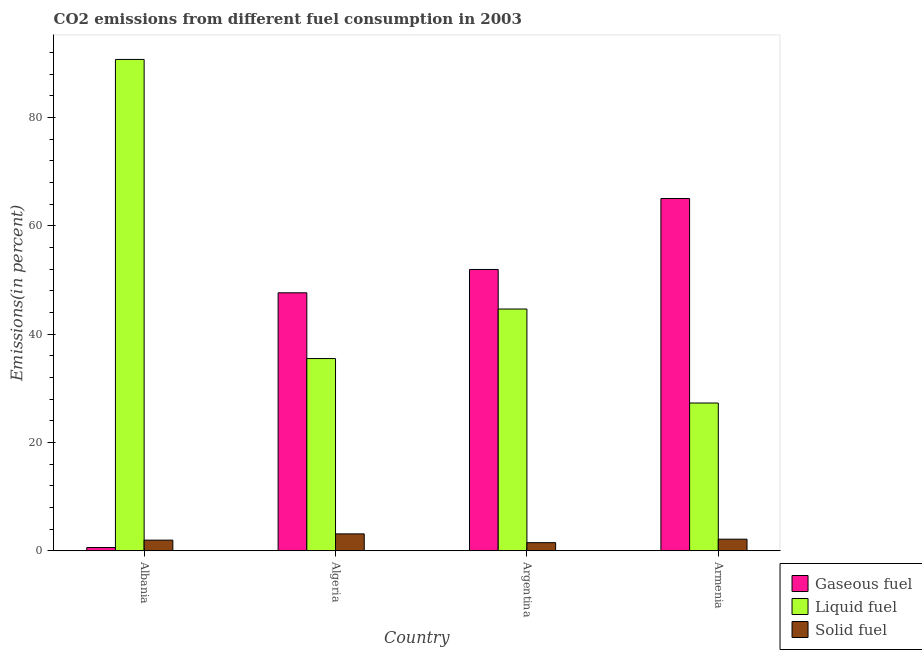How many groups of bars are there?
Offer a terse response. 4. Are the number of bars per tick equal to the number of legend labels?
Ensure brevity in your answer.  Yes. What is the label of the 4th group of bars from the left?
Make the answer very short. Armenia. In how many cases, is the number of bars for a given country not equal to the number of legend labels?
Give a very brief answer. 0. What is the percentage of solid fuel emission in Argentina?
Your answer should be very brief. 1.5. Across all countries, what is the maximum percentage of liquid fuel emission?
Your answer should be compact. 90.69. Across all countries, what is the minimum percentage of solid fuel emission?
Provide a succinct answer. 1.5. In which country was the percentage of solid fuel emission maximum?
Your response must be concise. Algeria. What is the total percentage of liquid fuel emission in the graph?
Your answer should be very brief. 198.07. What is the difference between the percentage of solid fuel emission in Algeria and that in Argentina?
Keep it short and to the point. 1.62. What is the difference between the percentage of liquid fuel emission in Algeria and the percentage of gaseous fuel emission in Albania?
Your response must be concise. 34.88. What is the average percentage of gaseous fuel emission per country?
Your answer should be compact. 41.29. What is the difference between the percentage of liquid fuel emission and percentage of gaseous fuel emission in Albania?
Offer a very short reply. 90.09. In how many countries, is the percentage of solid fuel emission greater than 64 %?
Your answer should be compact. 0. What is the ratio of the percentage of solid fuel emission in Albania to that in Algeria?
Offer a terse response. 0.63. Is the percentage of solid fuel emission in Albania less than that in Argentina?
Give a very brief answer. No. Is the difference between the percentage of liquid fuel emission in Albania and Algeria greater than the difference between the percentage of solid fuel emission in Albania and Algeria?
Your response must be concise. Yes. What is the difference between the highest and the second highest percentage of gaseous fuel emission?
Keep it short and to the point. 13.1. What is the difference between the highest and the lowest percentage of liquid fuel emission?
Your answer should be compact. 63.42. Is the sum of the percentage of liquid fuel emission in Algeria and Argentina greater than the maximum percentage of solid fuel emission across all countries?
Provide a short and direct response. Yes. What does the 1st bar from the left in Albania represents?
Keep it short and to the point. Gaseous fuel. What does the 2nd bar from the right in Armenia represents?
Your answer should be very brief. Liquid fuel. Is it the case that in every country, the sum of the percentage of gaseous fuel emission and percentage of liquid fuel emission is greater than the percentage of solid fuel emission?
Give a very brief answer. Yes. How many bars are there?
Offer a very short reply. 12. Are all the bars in the graph horizontal?
Offer a very short reply. No. Are the values on the major ticks of Y-axis written in scientific E-notation?
Give a very brief answer. No. Does the graph contain any zero values?
Provide a succinct answer. No. How many legend labels are there?
Keep it short and to the point. 3. How are the legend labels stacked?
Offer a terse response. Vertical. What is the title of the graph?
Your answer should be compact. CO2 emissions from different fuel consumption in 2003. What is the label or title of the X-axis?
Make the answer very short. Country. What is the label or title of the Y-axis?
Your response must be concise. Emissions(in percent). What is the Emissions(in percent) of Gaseous fuel in Albania?
Keep it short and to the point. 0.6. What is the Emissions(in percent) in Liquid fuel in Albania?
Ensure brevity in your answer.  90.69. What is the Emissions(in percent) in Solid fuel in Albania?
Provide a succinct answer. 1.96. What is the Emissions(in percent) in Gaseous fuel in Algeria?
Offer a terse response. 47.62. What is the Emissions(in percent) of Liquid fuel in Algeria?
Provide a succinct answer. 35.48. What is the Emissions(in percent) of Solid fuel in Algeria?
Make the answer very short. 3.12. What is the Emissions(in percent) of Gaseous fuel in Argentina?
Your answer should be very brief. 51.93. What is the Emissions(in percent) of Liquid fuel in Argentina?
Provide a short and direct response. 44.62. What is the Emissions(in percent) in Solid fuel in Argentina?
Provide a succinct answer. 1.5. What is the Emissions(in percent) in Gaseous fuel in Armenia?
Your answer should be very brief. 65.03. What is the Emissions(in percent) of Liquid fuel in Armenia?
Provide a short and direct response. 27.27. What is the Emissions(in percent) in Solid fuel in Armenia?
Your answer should be very brief. 2.14. Across all countries, what is the maximum Emissions(in percent) in Gaseous fuel?
Your answer should be compact. 65.03. Across all countries, what is the maximum Emissions(in percent) of Liquid fuel?
Make the answer very short. 90.69. Across all countries, what is the maximum Emissions(in percent) of Solid fuel?
Give a very brief answer. 3.12. Across all countries, what is the minimum Emissions(in percent) in Gaseous fuel?
Keep it short and to the point. 0.6. Across all countries, what is the minimum Emissions(in percent) of Liquid fuel?
Keep it short and to the point. 27.27. Across all countries, what is the minimum Emissions(in percent) in Solid fuel?
Ensure brevity in your answer.  1.5. What is the total Emissions(in percent) of Gaseous fuel in the graph?
Make the answer very short. 165.17. What is the total Emissions(in percent) of Liquid fuel in the graph?
Provide a succinct answer. 198.07. What is the total Emissions(in percent) in Solid fuel in the graph?
Keep it short and to the point. 8.72. What is the difference between the Emissions(in percent) in Gaseous fuel in Albania and that in Algeria?
Keep it short and to the point. -47.02. What is the difference between the Emissions(in percent) of Liquid fuel in Albania and that in Algeria?
Make the answer very short. 55.21. What is the difference between the Emissions(in percent) in Solid fuel in Albania and that in Algeria?
Your answer should be very brief. -1.15. What is the difference between the Emissions(in percent) of Gaseous fuel in Albania and that in Argentina?
Offer a very short reply. -51.33. What is the difference between the Emissions(in percent) of Liquid fuel in Albania and that in Argentina?
Your answer should be very brief. 46.07. What is the difference between the Emissions(in percent) in Solid fuel in Albania and that in Argentina?
Keep it short and to the point. 0.47. What is the difference between the Emissions(in percent) in Gaseous fuel in Albania and that in Armenia?
Offer a very short reply. -64.43. What is the difference between the Emissions(in percent) in Liquid fuel in Albania and that in Armenia?
Provide a short and direct response. 63.42. What is the difference between the Emissions(in percent) in Solid fuel in Albania and that in Armenia?
Provide a short and direct response. -0.17. What is the difference between the Emissions(in percent) of Gaseous fuel in Algeria and that in Argentina?
Give a very brief answer. -4.31. What is the difference between the Emissions(in percent) in Liquid fuel in Algeria and that in Argentina?
Give a very brief answer. -9.14. What is the difference between the Emissions(in percent) of Solid fuel in Algeria and that in Argentina?
Make the answer very short. 1.62. What is the difference between the Emissions(in percent) of Gaseous fuel in Algeria and that in Armenia?
Make the answer very short. -17.41. What is the difference between the Emissions(in percent) in Liquid fuel in Algeria and that in Armenia?
Your answer should be very brief. 8.21. What is the difference between the Emissions(in percent) of Solid fuel in Algeria and that in Armenia?
Ensure brevity in your answer.  0.98. What is the difference between the Emissions(in percent) in Gaseous fuel in Argentina and that in Armenia?
Make the answer very short. -13.1. What is the difference between the Emissions(in percent) of Liquid fuel in Argentina and that in Armenia?
Your response must be concise. 17.35. What is the difference between the Emissions(in percent) in Solid fuel in Argentina and that in Armenia?
Your answer should be compact. -0.64. What is the difference between the Emissions(in percent) of Gaseous fuel in Albania and the Emissions(in percent) of Liquid fuel in Algeria?
Offer a terse response. -34.88. What is the difference between the Emissions(in percent) of Gaseous fuel in Albania and the Emissions(in percent) of Solid fuel in Algeria?
Offer a very short reply. -2.52. What is the difference between the Emissions(in percent) in Liquid fuel in Albania and the Emissions(in percent) in Solid fuel in Algeria?
Make the answer very short. 87.57. What is the difference between the Emissions(in percent) of Gaseous fuel in Albania and the Emissions(in percent) of Liquid fuel in Argentina?
Your answer should be very brief. -44.03. What is the difference between the Emissions(in percent) in Gaseous fuel in Albania and the Emissions(in percent) in Solid fuel in Argentina?
Make the answer very short. -0.9. What is the difference between the Emissions(in percent) of Liquid fuel in Albania and the Emissions(in percent) of Solid fuel in Argentina?
Provide a short and direct response. 89.2. What is the difference between the Emissions(in percent) in Gaseous fuel in Albania and the Emissions(in percent) in Liquid fuel in Armenia?
Give a very brief answer. -26.67. What is the difference between the Emissions(in percent) of Gaseous fuel in Albania and the Emissions(in percent) of Solid fuel in Armenia?
Your answer should be very brief. -1.54. What is the difference between the Emissions(in percent) of Liquid fuel in Albania and the Emissions(in percent) of Solid fuel in Armenia?
Give a very brief answer. 88.55. What is the difference between the Emissions(in percent) in Gaseous fuel in Algeria and the Emissions(in percent) in Liquid fuel in Argentina?
Make the answer very short. 3. What is the difference between the Emissions(in percent) in Gaseous fuel in Algeria and the Emissions(in percent) in Solid fuel in Argentina?
Ensure brevity in your answer.  46.12. What is the difference between the Emissions(in percent) of Liquid fuel in Algeria and the Emissions(in percent) of Solid fuel in Argentina?
Offer a very short reply. 33.98. What is the difference between the Emissions(in percent) of Gaseous fuel in Algeria and the Emissions(in percent) of Liquid fuel in Armenia?
Provide a short and direct response. 20.35. What is the difference between the Emissions(in percent) of Gaseous fuel in Algeria and the Emissions(in percent) of Solid fuel in Armenia?
Your answer should be compact. 45.48. What is the difference between the Emissions(in percent) in Liquid fuel in Algeria and the Emissions(in percent) in Solid fuel in Armenia?
Your response must be concise. 33.34. What is the difference between the Emissions(in percent) in Gaseous fuel in Argentina and the Emissions(in percent) in Liquid fuel in Armenia?
Give a very brief answer. 24.65. What is the difference between the Emissions(in percent) in Gaseous fuel in Argentina and the Emissions(in percent) in Solid fuel in Armenia?
Your answer should be very brief. 49.79. What is the difference between the Emissions(in percent) in Liquid fuel in Argentina and the Emissions(in percent) in Solid fuel in Armenia?
Give a very brief answer. 42.48. What is the average Emissions(in percent) of Gaseous fuel per country?
Make the answer very short. 41.29. What is the average Emissions(in percent) in Liquid fuel per country?
Ensure brevity in your answer.  49.52. What is the average Emissions(in percent) in Solid fuel per country?
Give a very brief answer. 2.18. What is the difference between the Emissions(in percent) of Gaseous fuel and Emissions(in percent) of Liquid fuel in Albania?
Make the answer very short. -90.09. What is the difference between the Emissions(in percent) in Gaseous fuel and Emissions(in percent) in Solid fuel in Albania?
Keep it short and to the point. -1.37. What is the difference between the Emissions(in percent) in Liquid fuel and Emissions(in percent) in Solid fuel in Albania?
Offer a very short reply. 88.73. What is the difference between the Emissions(in percent) in Gaseous fuel and Emissions(in percent) in Liquid fuel in Algeria?
Give a very brief answer. 12.14. What is the difference between the Emissions(in percent) of Gaseous fuel and Emissions(in percent) of Solid fuel in Algeria?
Provide a succinct answer. 44.5. What is the difference between the Emissions(in percent) of Liquid fuel and Emissions(in percent) of Solid fuel in Algeria?
Offer a terse response. 32.36. What is the difference between the Emissions(in percent) of Gaseous fuel and Emissions(in percent) of Liquid fuel in Argentina?
Provide a succinct answer. 7.3. What is the difference between the Emissions(in percent) in Gaseous fuel and Emissions(in percent) in Solid fuel in Argentina?
Your response must be concise. 50.43. What is the difference between the Emissions(in percent) in Liquid fuel and Emissions(in percent) in Solid fuel in Argentina?
Offer a very short reply. 43.13. What is the difference between the Emissions(in percent) of Gaseous fuel and Emissions(in percent) of Liquid fuel in Armenia?
Your answer should be compact. 37.75. What is the difference between the Emissions(in percent) of Gaseous fuel and Emissions(in percent) of Solid fuel in Armenia?
Provide a short and direct response. 62.89. What is the difference between the Emissions(in percent) in Liquid fuel and Emissions(in percent) in Solid fuel in Armenia?
Your answer should be compact. 25.13. What is the ratio of the Emissions(in percent) of Gaseous fuel in Albania to that in Algeria?
Make the answer very short. 0.01. What is the ratio of the Emissions(in percent) of Liquid fuel in Albania to that in Algeria?
Make the answer very short. 2.56. What is the ratio of the Emissions(in percent) in Solid fuel in Albania to that in Algeria?
Offer a terse response. 0.63. What is the ratio of the Emissions(in percent) in Gaseous fuel in Albania to that in Argentina?
Provide a succinct answer. 0.01. What is the ratio of the Emissions(in percent) in Liquid fuel in Albania to that in Argentina?
Keep it short and to the point. 2.03. What is the ratio of the Emissions(in percent) of Solid fuel in Albania to that in Argentina?
Keep it short and to the point. 1.31. What is the ratio of the Emissions(in percent) in Gaseous fuel in Albania to that in Armenia?
Your answer should be very brief. 0.01. What is the ratio of the Emissions(in percent) of Liquid fuel in Albania to that in Armenia?
Make the answer very short. 3.33. What is the ratio of the Emissions(in percent) of Solid fuel in Albania to that in Armenia?
Offer a terse response. 0.92. What is the ratio of the Emissions(in percent) of Gaseous fuel in Algeria to that in Argentina?
Provide a short and direct response. 0.92. What is the ratio of the Emissions(in percent) of Liquid fuel in Algeria to that in Argentina?
Your answer should be compact. 0.8. What is the ratio of the Emissions(in percent) in Solid fuel in Algeria to that in Argentina?
Make the answer very short. 2.09. What is the ratio of the Emissions(in percent) in Gaseous fuel in Algeria to that in Armenia?
Provide a short and direct response. 0.73. What is the ratio of the Emissions(in percent) of Liquid fuel in Algeria to that in Armenia?
Make the answer very short. 1.3. What is the ratio of the Emissions(in percent) of Solid fuel in Algeria to that in Armenia?
Give a very brief answer. 1.46. What is the ratio of the Emissions(in percent) of Gaseous fuel in Argentina to that in Armenia?
Keep it short and to the point. 0.8. What is the ratio of the Emissions(in percent) of Liquid fuel in Argentina to that in Armenia?
Your response must be concise. 1.64. What is the ratio of the Emissions(in percent) of Solid fuel in Argentina to that in Armenia?
Offer a very short reply. 0.7. What is the difference between the highest and the second highest Emissions(in percent) of Gaseous fuel?
Offer a very short reply. 13.1. What is the difference between the highest and the second highest Emissions(in percent) in Liquid fuel?
Keep it short and to the point. 46.07. What is the difference between the highest and the second highest Emissions(in percent) in Solid fuel?
Your answer should be very brief. 0.98. What is the difference between the highest and the lowest Emissions(in percent) of Gaseous fuel?
Give a very brief answer. 64.43. What is the difference between the highest and the lowest Emissions(in percent) in Liquid fuel?
Provide a short and direct response. 63.42. What is the difference between the highest and the lowest Emissions(in percent) in Solid fuel?
Keep it short and to the point. 1.62. 